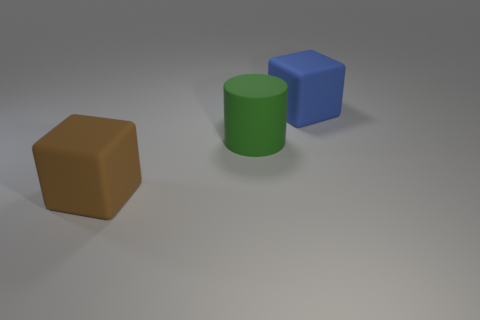Add 2 large purple rubber cylinders. How many objects exist? 5 Subtract all cylinders. How many objects are left? 2 Add 1 blue rubber things. How many blue rubber things are left? 2 Add 3 big blue matte objects. How many big blue matte objects exist? 4 Subtract 0 yellow cylinders. How many objects are left? 3 Subtract all large metallic cubes. Subtract all large brown matte blocks. How many objects are left? 2 